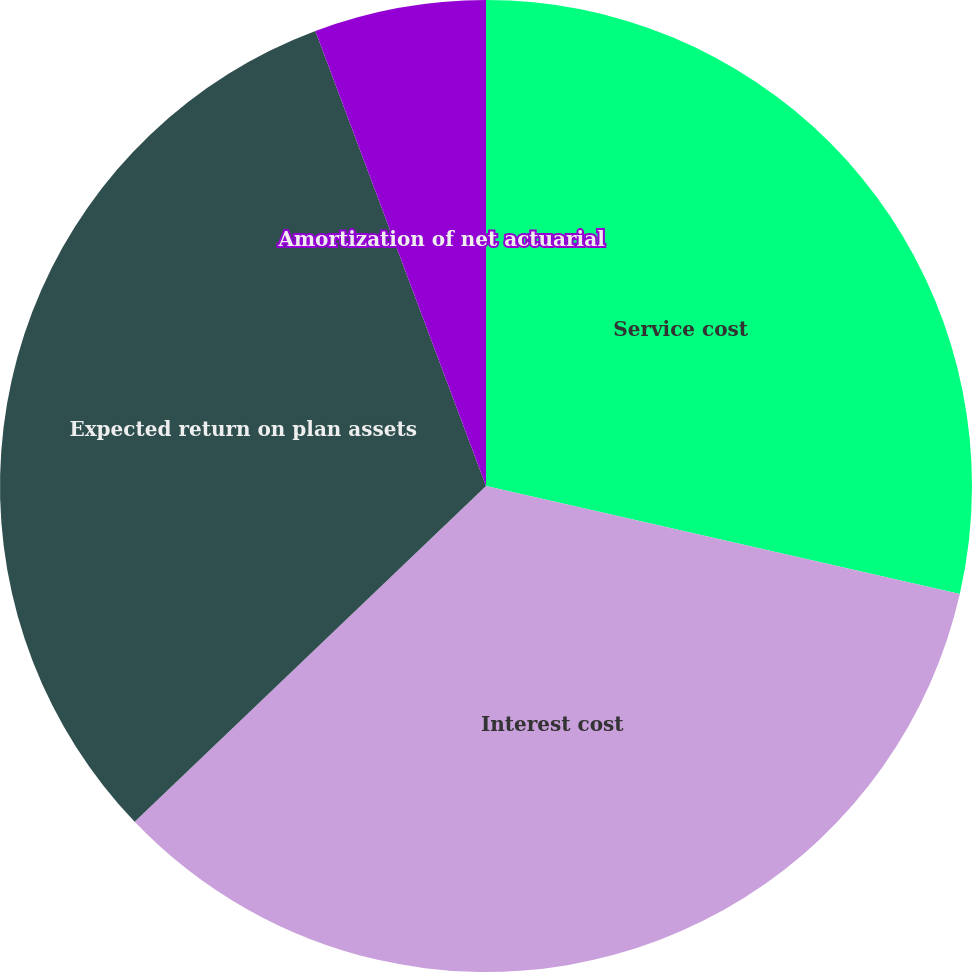Convert chart to OTSL. <chart><loc_0><loc_0><loc_500><loc_500><pie_chart><fcel>Service cost<fcel>Interest cost<fcel>Expected return on plan assets<fcel>Amortization of net actuarial<nl><fcel>28.57%<fcel>34.29%<fcel>31.43%<fcel>5.71%<nl></chart> 